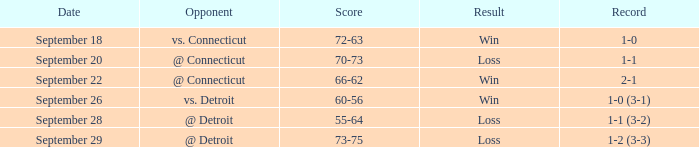What is the total with a record of 1-0? 72-63. 